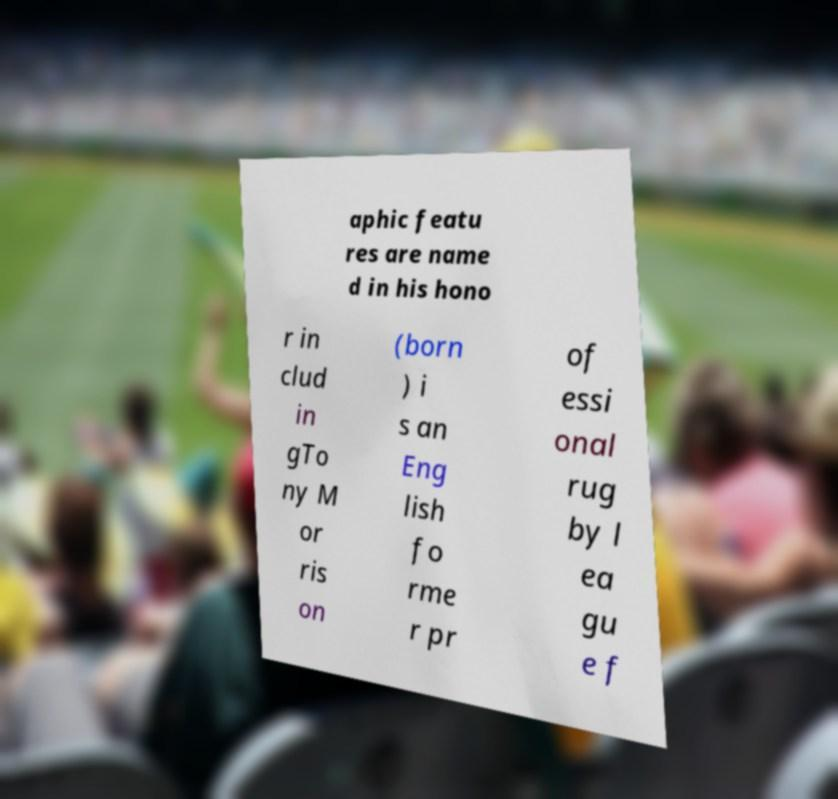For documentation purposes, I need the text within this image transcribed. Could you provide that? aphic featu res are name d in his hono r in clud in gTo ny M or ris on (born ) i s an Eng lish fo rme r pr of essi onal rug by l ea gu e f 